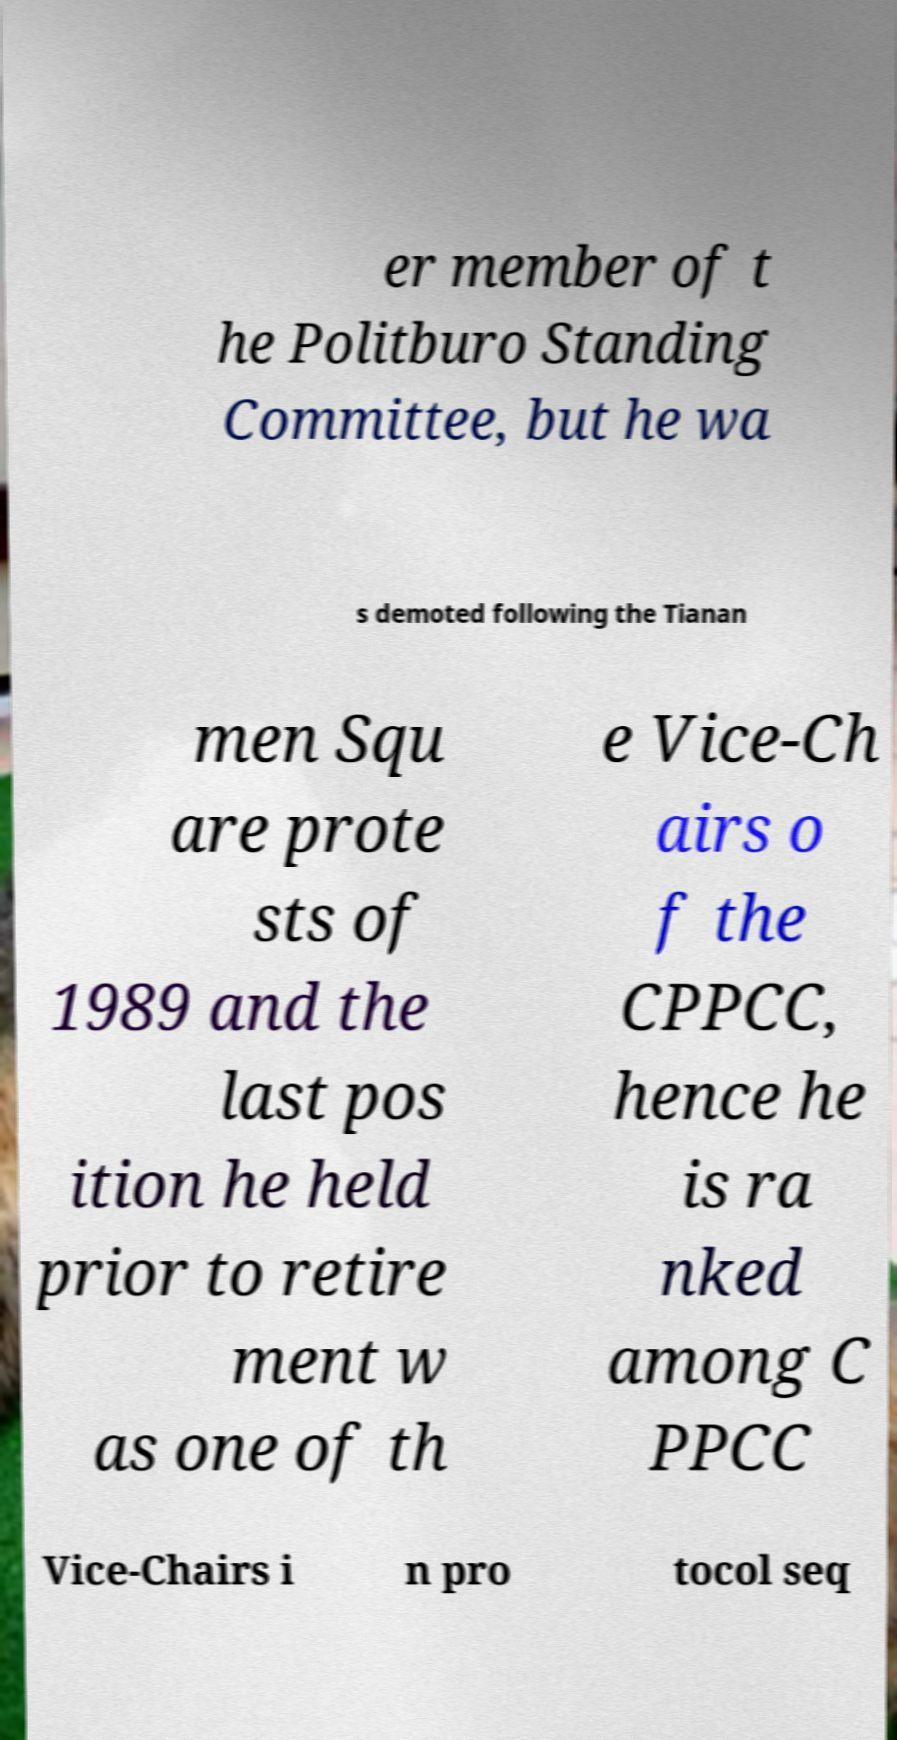For documentation purposes, I need the text within this image transcribed. Could you provide that? er member of t he Politburo Standing Committee, but he wa s demoted following the Tianan men Squ are prote sts of 1989 and the last pos ition he held prior to retire ment w as one of th e Vice-Ch airs o f the CPPCC, hence he is ra nked among C PPCC Vice-Chairs i n pro tocol seq 